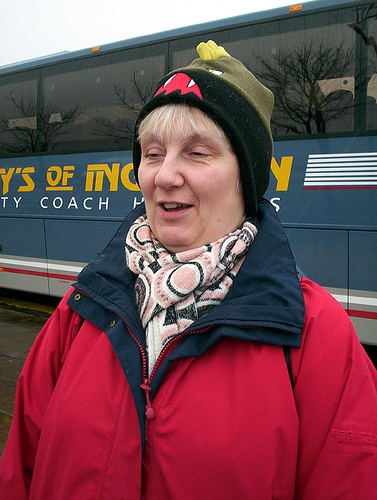Describe the objects in this image and their specific colors. I can see people in white, brown, and black tones and bus in white, blue, black, gray, and lightgray tones in this image. 